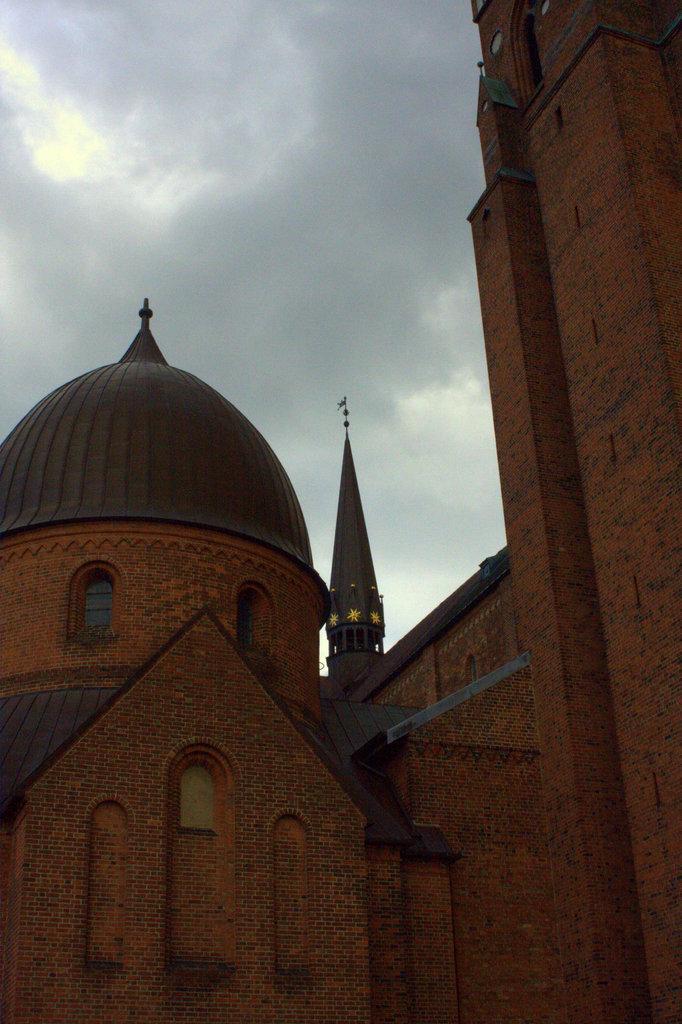Please provide a concise description of this image. In this image we can see buildings, windows and clouds in the sky. 